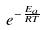Convert formula to latex. <formula><loc_0><loc_0><loc_500><loc_500>e ^ { - \frac { E _ { a } } { R T } }</formula> 